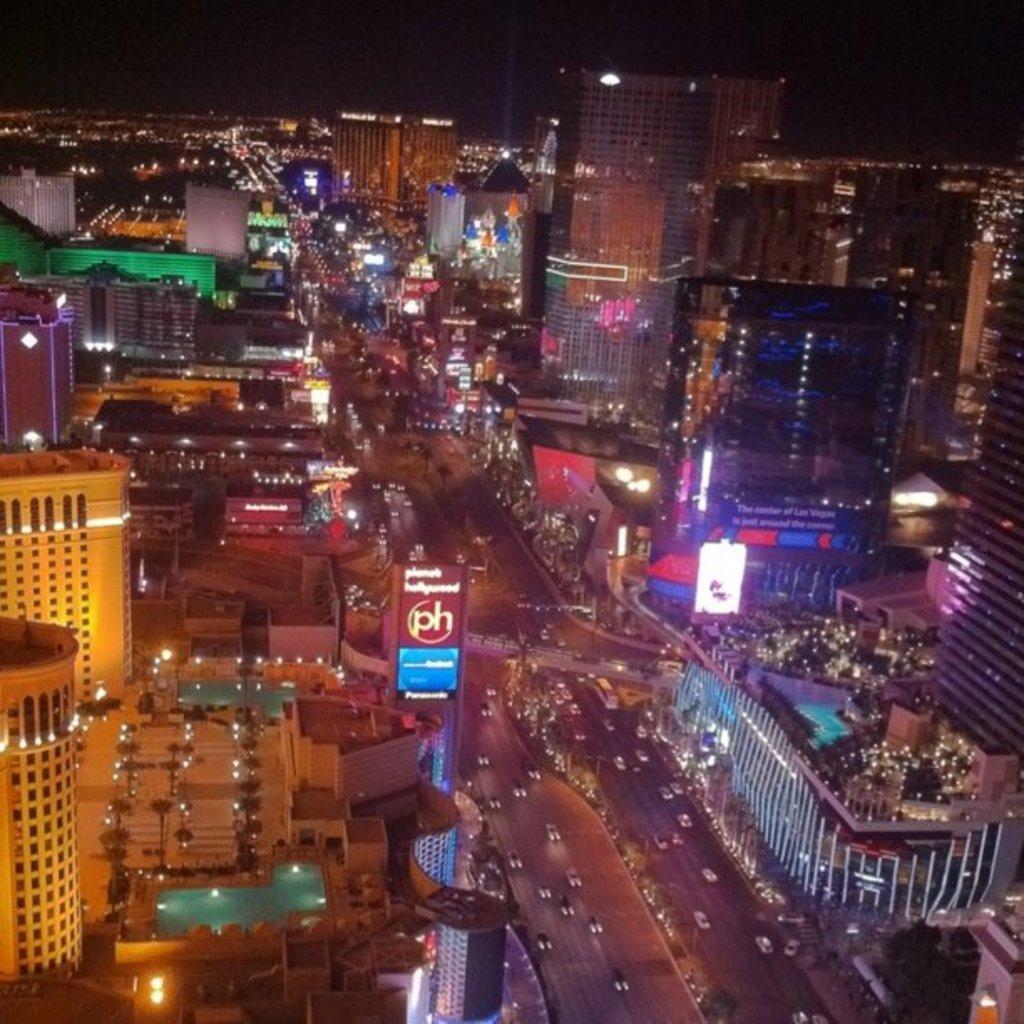In one or two sentences, can you explain what this image depicts? In this image, I can see the view of the city. These are the buildings with the lights. This looks like a board, which is attached to a pole. I can see the vehicles on the road. At the bottom right side of the image, that looks like a tree. 